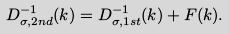<formula> <loc_0><loc_0><loc_500><loc_500>D ^ { - 1 } _ { \sigma , 2 n d } ( k ) = D ^ { - 1 } _ { \sigma , 1 s t } ( k ) + F ( k ) .</formula> 